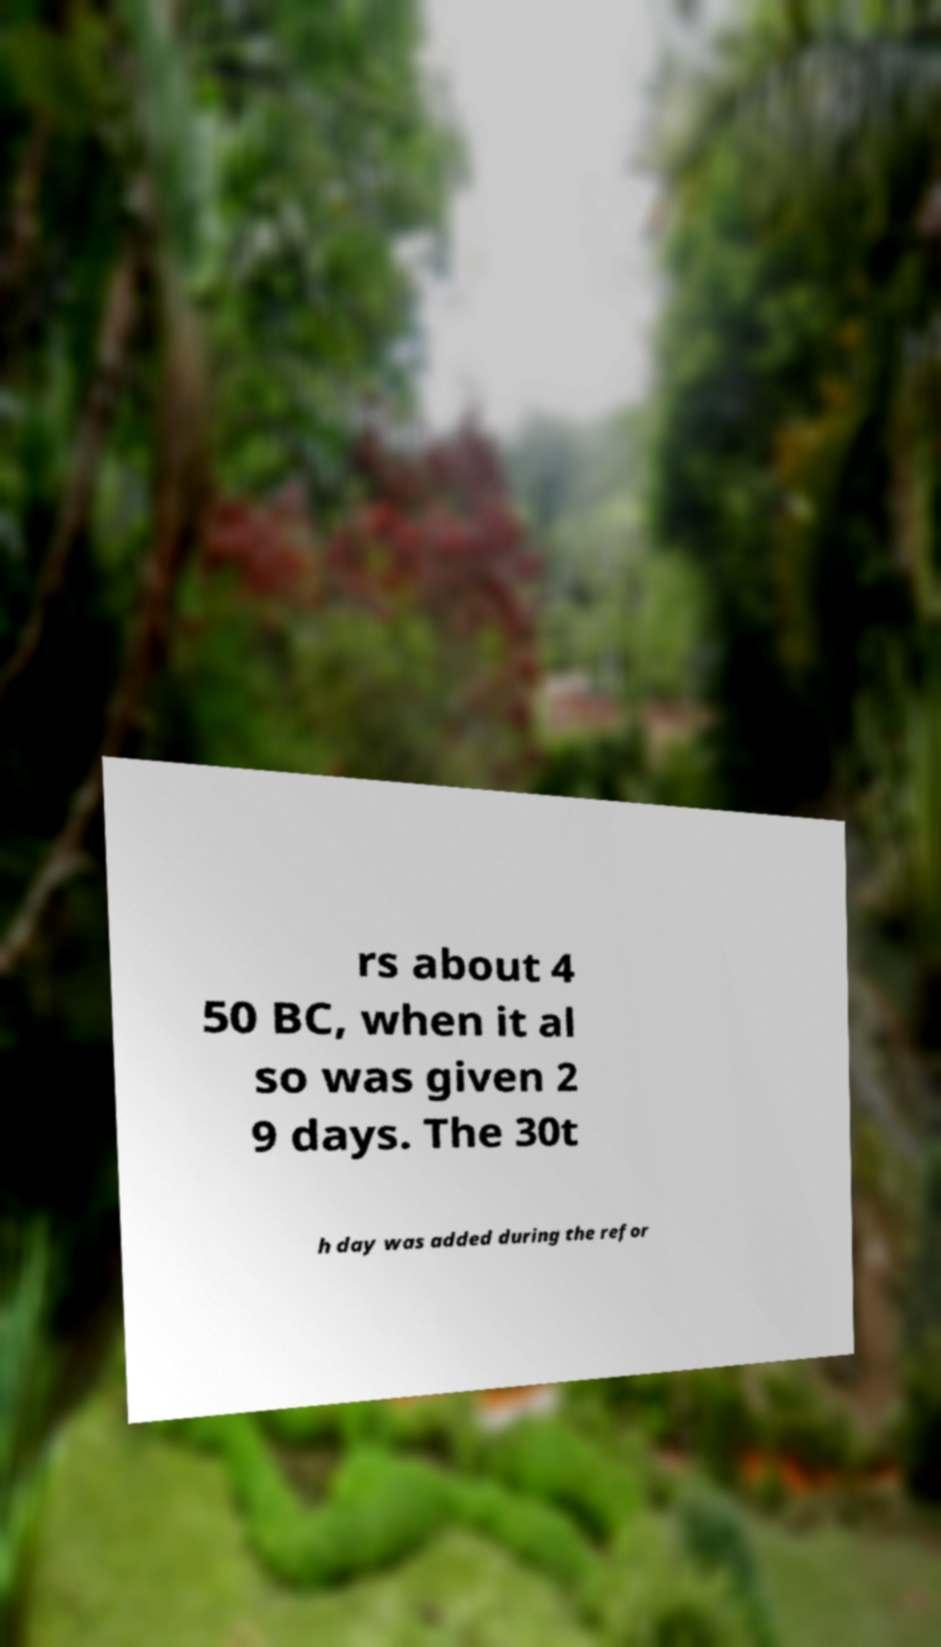Can you read and provide the text displayed in the image?This photo seems to have some interesting text. Can you extract and type it out for me? rs about 4 50 BC, when it al so was given 2 9 days. The 30t h day was added during the refor 